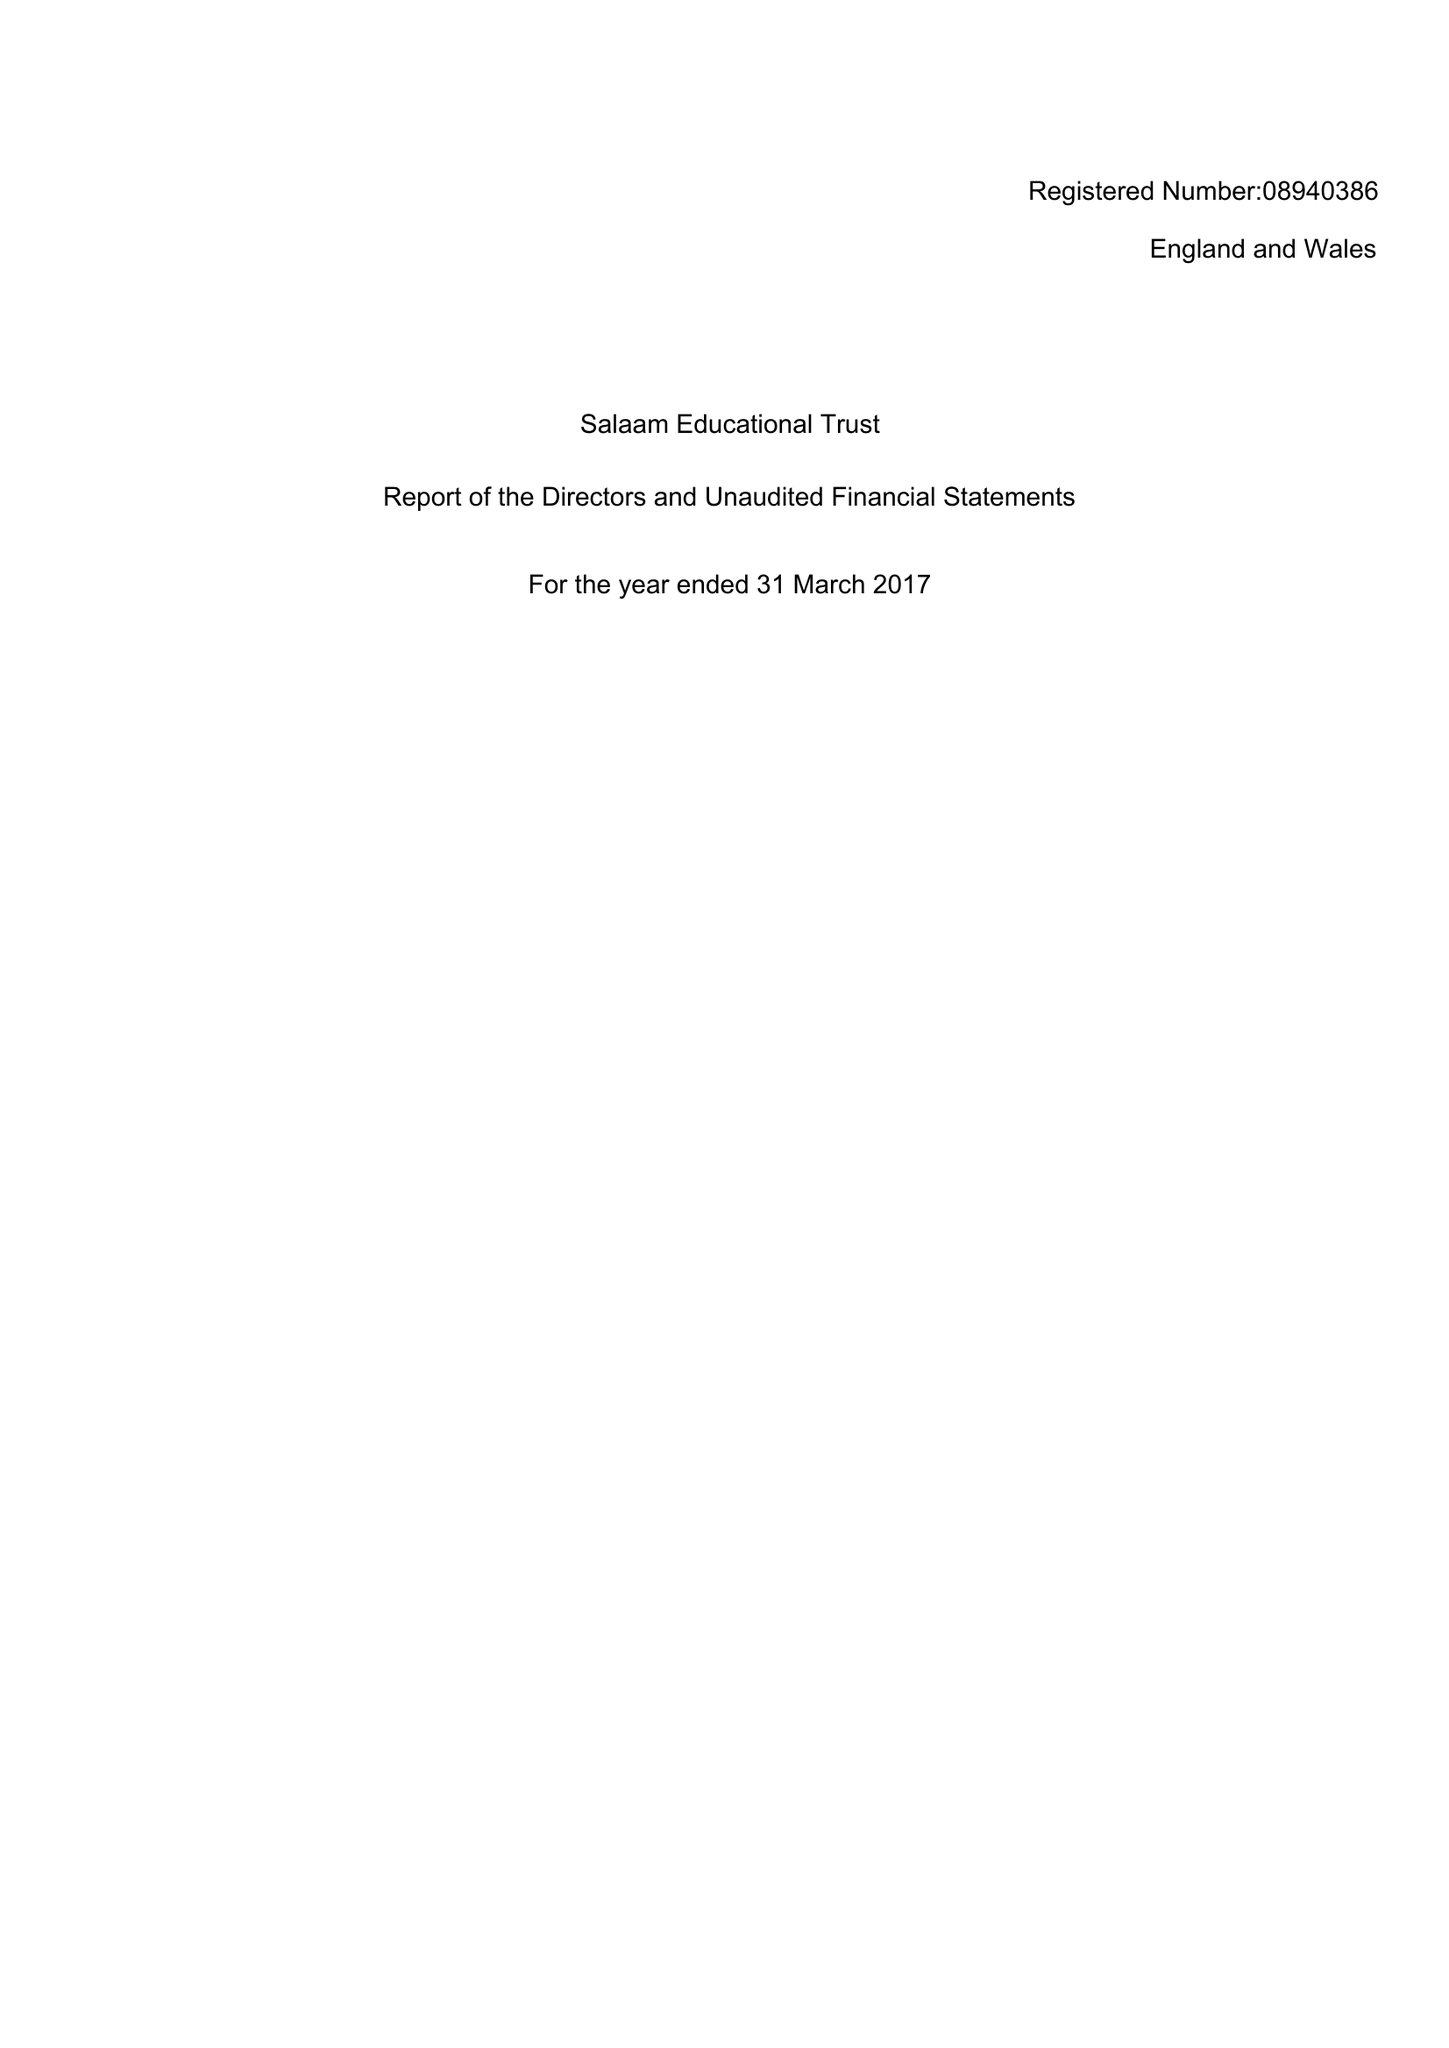What is the value for the address__post_town?
Answer the question using a single word or phrase. PRESTON 